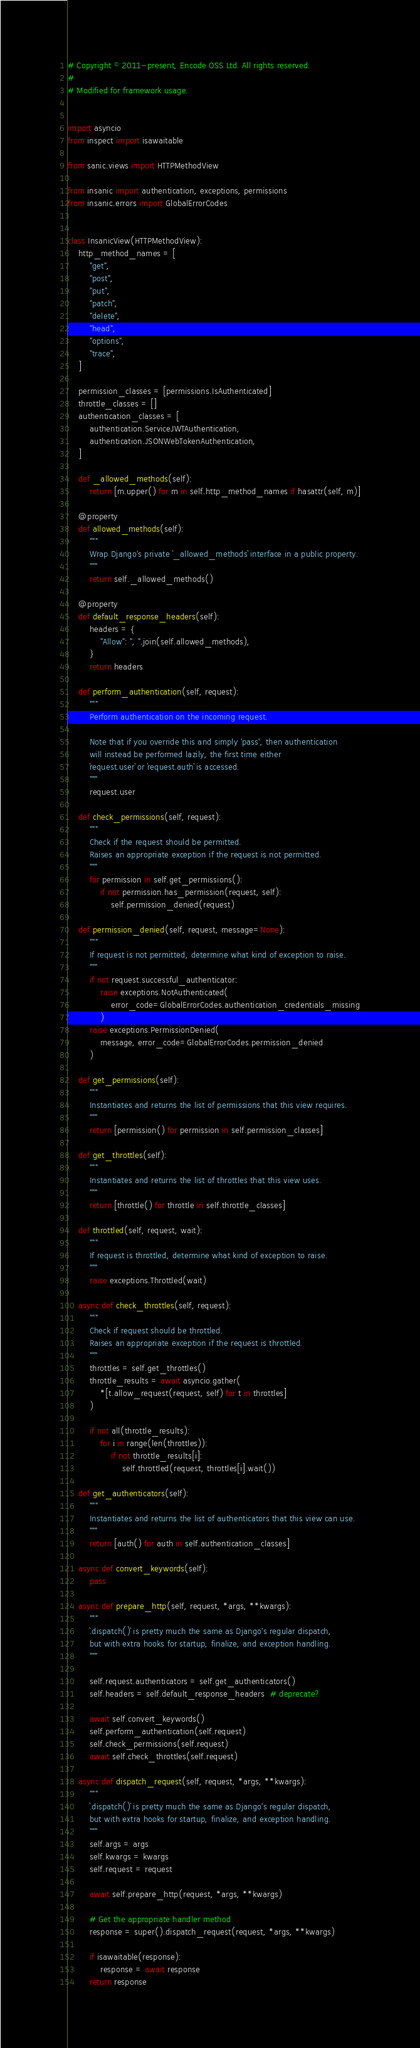<code> <loc_0><loc_0><loc_500><loc_500><_Python_># Copyright © 2011-present, Encode OSS Ltd. All rights reserved.
#
# Modified for framework usage.


import asyncio
from inspect import isawaitable

from sanic.views import HTTPMethodView

from insanic import authentication, exceptions, permissions
from insanic.errors import GlobalErrorCodes


class InsanicView(HTTPMethodView):
    http_method_names = [
        "get",
        "post",
        "put",
        "patch",
        "delete",
        "head",
        "options",
        "trace",
    ]

    permission_classes = [permissions.IsAuthenticated]
    throttle_classes = []
    authentication_classes = [
        authentication.ServiceJWTAuthentication,
        authentication.JSONWebTokenAuthentication,
    ]

    def _allowed_methods(self):
        return [m.upper() for m in self.http_method_names if hasattr(self, m)]

    @property
    def allowed_methods(self):
        """
        Wrap Django's private `_allowed_methods` interface in a public property.
        """
        return self._allowed_methods()

    @property
    def default_response_headers(self):
        headers = {
            "Allow": ", ".join(self.allowed_methods),
        }
        return headers

    def perform_authentication(self, request):
        """
        Perform authentication on the incoming request.

        Note that if you override this and simply 'pass', then authentication
        will instead be performed lazily, the first time either
        `request.user` or `request.auth` is accessed.
        """
        request.user

    def check_permissions(self, request):
        """
        Check if the request should be permitted.
        Raises an appropriate exception if the request is not permitted.
        """
        for permission in self.get_permissions():
            if not permission.has_permission(request, self):
                self.permission_denied(request)

    def permission_denied(self, request, message=None):
        """
        If request is not permitted, determine what kind of exception to raise.
        """
        if not request.successful_authenticator:
            raise exceptions.NotAuthenticated(
                error_code=GlobalErrorCodes.authentication_credentials_missing
            )
        raise exceptions.PermissionDenied(
            message, error_code=GlobalErrorCodes.permission_denied
        )

    def get_permissions(self):
        """
        Instantiates and returns the list of permissions that this view requires.
        """
        return [permission() for permission in self.permission_classes]

    def get_throttles(self):
        """
        Instantiates and returns the list of throttles that this view uses.
        """
        return [throttle() for throttle in self.throttle_classes]

    def throttled(self, request, wait):
        """
        If request is throttled, determine what kind of exception to raise.
        """
        raise exceptions.Throttled(wait)

    async def check_throttles(self, request):
        """
        Check if request should be throttled.
        Raises an appropriate exception if the request is throttled.
        """
        throttles = self.get_throttles()
        throttle_results = await asyncio.gather(
            *[t.allow_request(request, self) for t in throttles]
        )

        if not all(throttle_results):
            for i in range(len(throttles)):
                if not throttle_results[i]:
                    self.throttled(request, throttles[i].wait())

    def get_authenticators(self):
        """
        Instantiates and returns the list of authenticators that this view can use.
        """
        return [auth() for auth in self.authentication_classes]

    async def convert_keywords(self):
        pass

    async def prepare_http(self, request, *args, **kwargs):
        """
        `.dispatch()` is pretty much the same as Django's regular dispatch,
        but with extra hooks for startup, finalize, and exception handling.
        """

        self.request.authenticators = self.get_authenticators()
        self.headers = self.default_response_headers  # deprecate?

        await self.convert_keywords()
        self.perform_authentication(self.request)
        self.check_permissions(self.request)
        await self.check_throttles(self.request)

    async def dispatch_request(self, request, *args, **kwargs):
        """
        `.dispatch()` is pretty much the same as Django's regular dispatch,
        but with extra hooks for startup, finalize, and exception handling.
        """
        self.args = args
        self.kwargs = kwargs
        self.request = request

        await self.prepare_http(request, *args, **kwargs)

        # Get the appropriate handler method
        response = super().dispatch_request(request, *args, **kwargs)

        if isawaitable(response):
            response = await response
        return response
</code> 